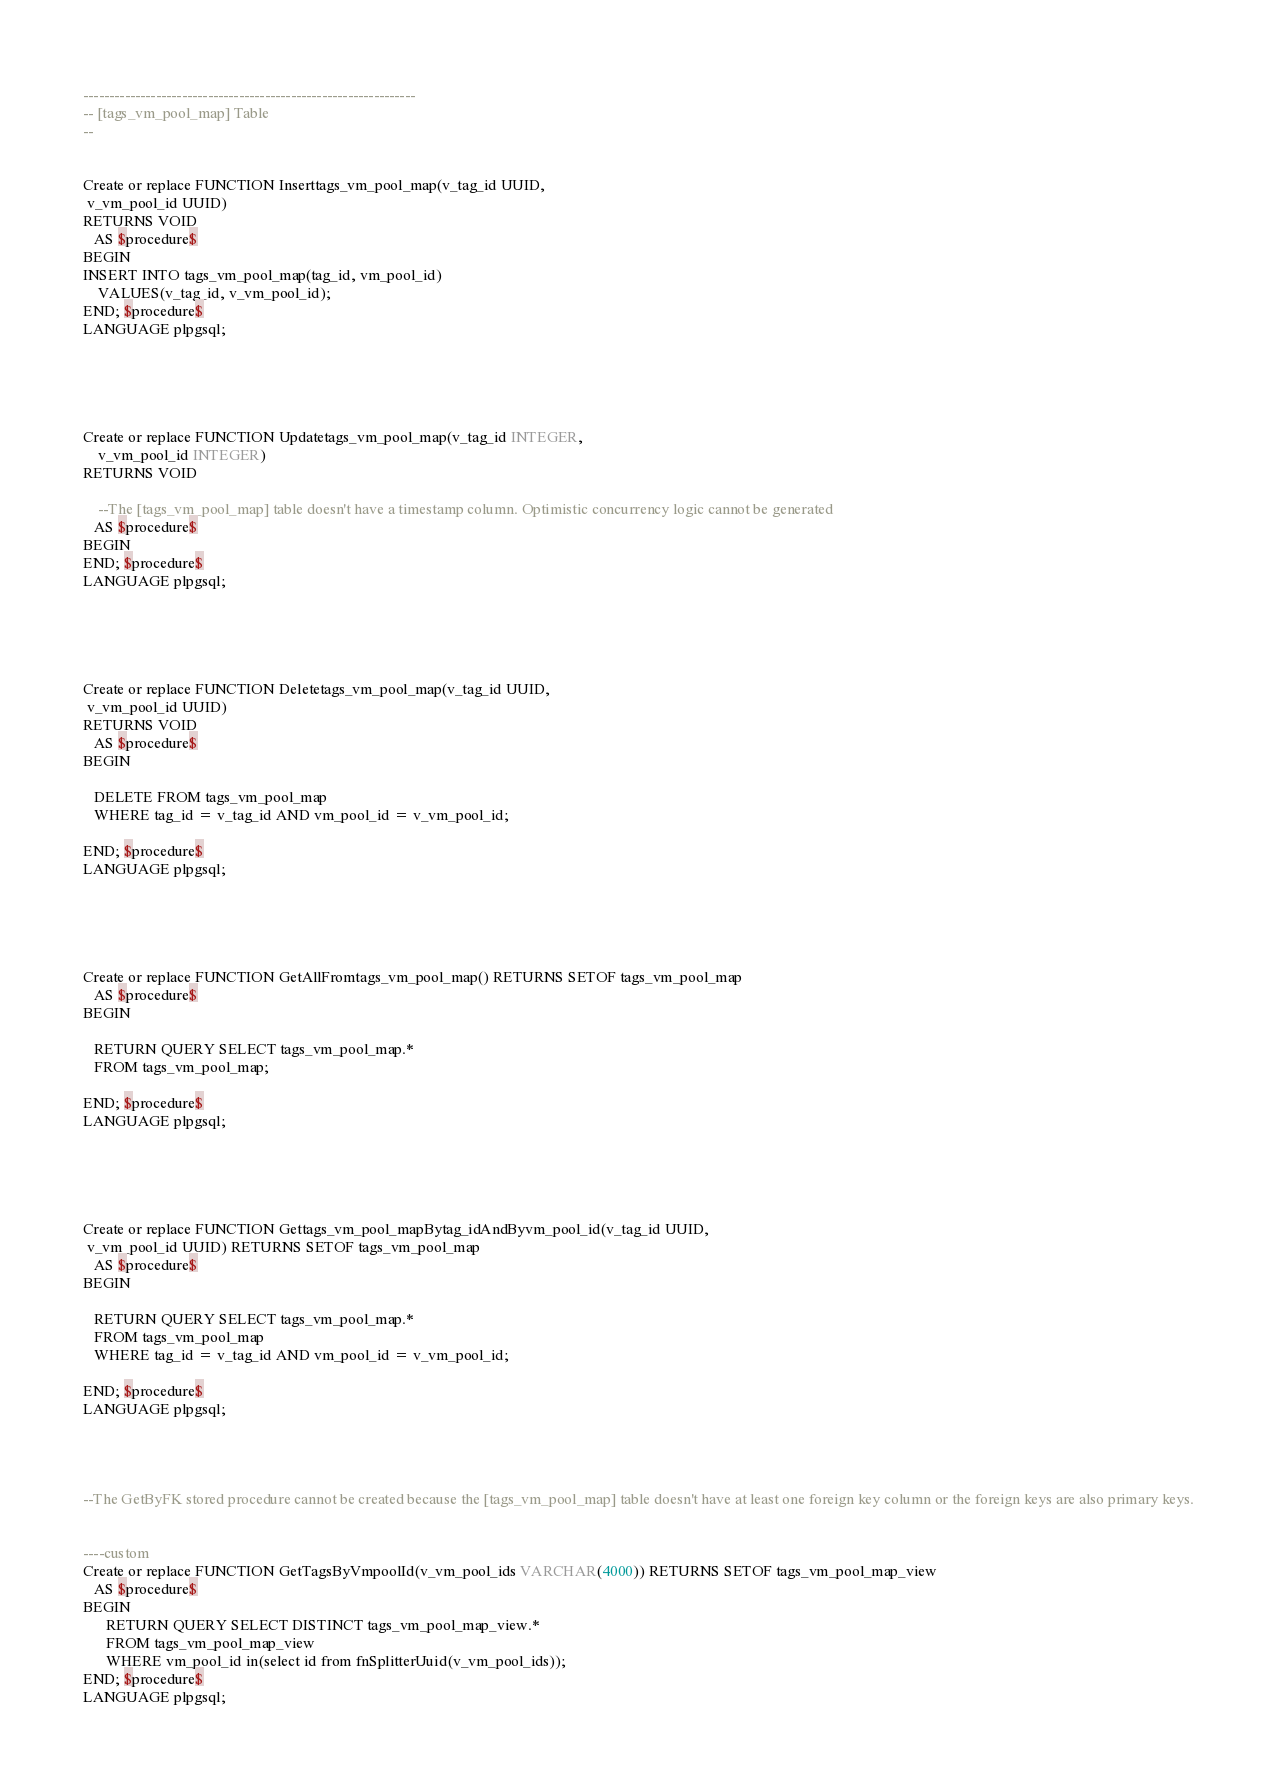<code> <loc_0><loc_0><loc_500><loc_500><_SQL_>----------------------------------------------------------------
-- [tags_vm_pool_map] Table
--


Create or replace FUNCTION Inserttags_vm_pool_map(v_tag_id UUID,  
 v_vm_pool_id UUID)
RETURNS VOID
   AS $procedure$
BEGIN
INSERT INTO tags_vm_pool_map(tag_id, vm_pool_id)
	VALUES(v_tag_id, v_vm_pool_id);
END; $procedure$
LANGUAGE plpgsql;    





Create or replace FUNCTION Updatetags_vm_pool_map(v_tag_id INTEGER,
	v_vm_pool_id INTEGER)
RETURNS VOID

	--The [tags_vm_pool_map] table doesn't have a timestamp column. Optimistic concurrency logic cannot be generated
   AS $procedure$
BEGIN
END; $procedure$
LANGUAGE plpgsql;





Create or replace FUNCTION Deletetags_vm_pool_map(v_tag_id UUID,  
 v_vm_pool_id UUID)
RETURNS VOID
   AS $procedure$
BEGIN
	
   DELETE FROM tags_vm_pool_map
   WHERE tag_id = v_tag_id AND vm_pool_id = v_vm_pool_id;
    
END; $procedure$
LANGUAGE plpgsql;





Create or replace FUNCTION GetAllFromtags_vm_pool_map() RETURNS SETOF tags_vm_pool_map
   AS $procedure$
BEGIN
	
   RETURN QUERY SELECT tags_vm_pool_map.*
   FROM tags_vm_pool_map;

END; $procedure$
LANGUAGE plpgsql;





Create or replace FUNCTION Gettags_vm_pool_mapBytag_idAndByvm_pool_id(v_tag_id UUID,  
 v_vm_pool_id UUID) RETURNS SETOF tags_vm_pool_map
   AS $procedure$
BEGIN
	
   RETURN QUERY SELECT tags_vm_pool_map.*
   FROM tags_vm_pool_map
   WHERE tag_id = v_tag_id AND vm_pool_id = v_vm_pool_id;

END; $procedure$
LANGUAGE plpgsql;




--The GetByFK stored procedure cannot be created because the [tags_vm_pool_map] table doesn't have at least one foreign key column or the foreign keys are also primary keys.


----custom
Create or replace FUNCTION GetTagsByVmpoolId(v_vm_pool_ids VARCHAR(4000)) RETURNS SETOF tags_vm_pool_map_view
   AS $procedure$
BEGIN
      RETURN QUERY SELECT DISTINCT tags_vm_pool_map_view.*
      FROM tags_vm_pool_map_view
      WHERE vm_pool_id in(select id from fnSplitterUuid(v_vm_pool_ids));
END; $procedure$
LANGUAGE plpgsql;
</code> 